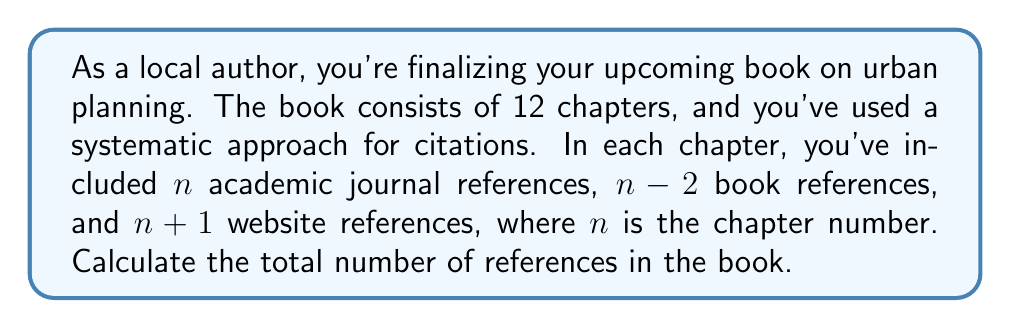Help me with this question. Let's approach this step-by-step:

1) For each chapter, the number of references is:
   - Academic journal references: $n$
   - Book references: $n-2$
   - Website references: $n+1$

2) Total references per chapter: $n + (n-2) + (n+1) = 3n - 1$

3) We need to sum this for all 12 chapters. This forms an arithmetic sequence with:
   - First term $a_1 = 3(1) - 1 = 2$
   - Last term $a_{12} = 3(12) - 1 = 35$

4) For an arithmetic sequence, the sum is given by:
   $$S_n = \frac{n}{2}(a_1 + a_n)$$
   where $n$ is the number of terms.

5) Substituting our values:
   $$S_{12} = \frac{12}{2}(2 + 35) = 6(37) = 222$$

Therefore, the total number of references in the book is 222.
Answer: 222 references 